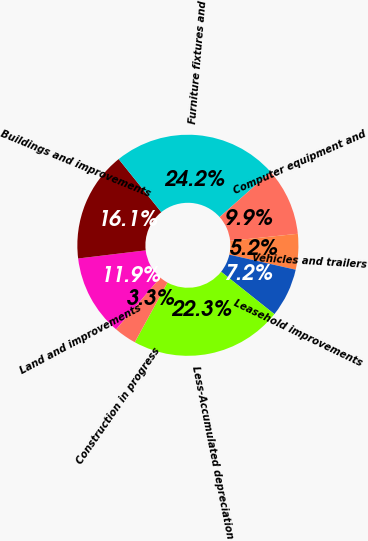<chart> <loc_0><loc_0><loc_500><loc_500><pie_chart><fcel>Land and improvements<fcel>Buildings and improvements<fcel>Furniture fixtures and<fcel>Computer equipment and<fcel>Vehicles and trailers<fcel>Leasehold improvements<fcel>Less-Accumulated depreciation<fcel>Construction in progress<nl><fcel>11.85%<fcel>16.14%<fcel>24.21%<fcel>9.9%<fcel>5.21%<fcel>7.15%<fcel>22.27%<fcel>3.27%<nl></chart> 